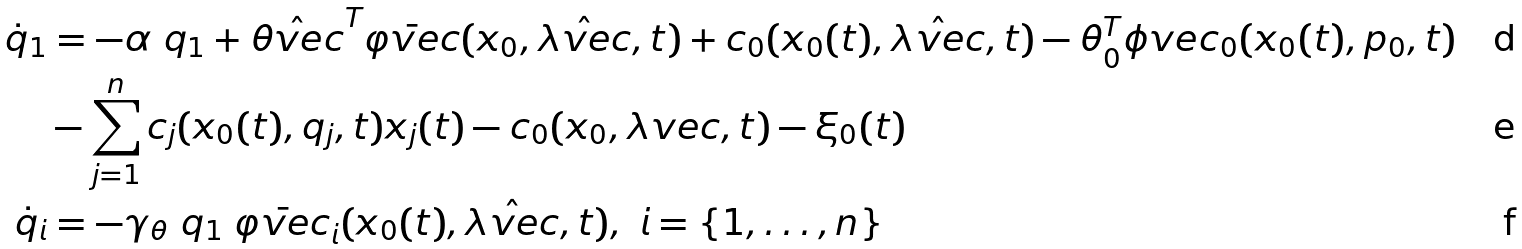<formula> <loc_0><loc_0><loc_500><loc_500>\dot { q } _ { 1 } & = - \alpha \ q _ { 1 } + \hat { \theta v e c } ^ { T } \bar { \varphi v e c } ( x _ { 0 } , \hat { \lambda v e c } , t ) + c _ { 0 } ( x _ { 0 } ( t ) , \hat { \lambda v e c } , t ) - \theta _ { 0 } ^ { T } \phi v e c _ { 0 } ( x _ { 0 } ( t ) , p _ { 0 } , t ) \\ & - \sum _ { j = 1 } ^ { n } c _ { j } ( x _ { 0 } ( t ) , q _ { j } , t ) x _ { j } ( t ) - c _ { 0 } ( x _ { 0 } , \lambda v e c , t ) - \xi _ { 0 } ( t ) \\ \dot { q } _ { i } & = - \gamma _ { \theta } \ q _ { 1 } \ \bar { \varphi v e c } _ { i } ( x _ { 0 } ( t ) , \hat { \lambda v e c } , t ) , \ i = \{ 1 , \dots , n \}</formula> 